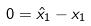<formula> <loc_0><loc_0><loc_500><loc_500>0 = \hat { x } _ { 1 } - x _ { 1 }</formula> 